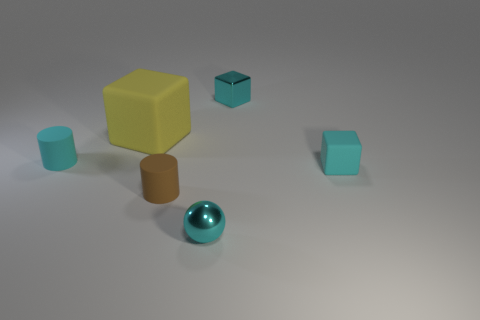What number of other objects are there of the same size as the cyan cylinder?
Offer a very short reply. 4. There is a small cube that is behind the yellow object; what is its color?
Offer a terse response. Cyan. Are the tiny cylinder in front of the cyan cylinder and the large yellow thing made of the same material?
Give a very brief answer. Yes. What number of objects are both behind the small matte block and to the left of the shiny block?
Ensure brevity in your answer.  2. What color is the metal thing that is to the left of the small block behind the tiny cyan matte thing that is on the left side of the yellow thing?
Provide a short and direct response. Cyan. What number of other objects are the same shape as the brown matte thing?
Provide a succinct answer. 1. Are there any shiny objects that are left of the object that is behind the big yellow matte cube?
Offer a terse response. Yes. What number of rubber things are either green cylinders or tiny spheres?
Give a very brief answer. 0. There is a tiny thing that is in front of the cyan rubber cube and behind the tiny shiny ball; what is its material?
Provide a succinct answer. Rubber. There is a tiny cyan rubber cylinder that is on the left side of the metallic object behind the small metallic sphere; is there a cyan block behind it?
Your answer should be very brief. Yes. 